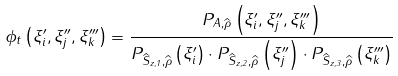<formula> <loc_0><loc_0><loc_500><loc_500>\phi _ { t } \left ( \xi _ { i } ^ { \prime } , \xi _ { j } ^ { \prime \prime } , \xi _ { k } ^ { \prime \prime \prime } \right ) = \frac { P _ { A , \widehat { \rho } } \left ( \xi _ { i } ^ { \prime } , \xi _ { j } ^ { \prime \prime } , \xi _ { k } ^ { \prime \prime \prime } \right ) } { P _ { \widehat { S } _ { z , 1 } , \widehat { \rho } } \left ( \xi _ { i } ^ { \prime } \right ) \cdot P _ { \widehat { S } _ { z , 2 } , \widehat { \rho } } \left ( \xi _ { j } ^ { \prime \prime } \right ) \cdot P _ { \widehat { S } _ { z , 3 } , \widehat { \rho } } \left ( \xi _ { k } ^ { \prime \prime \prime } \right ) }</formula> 